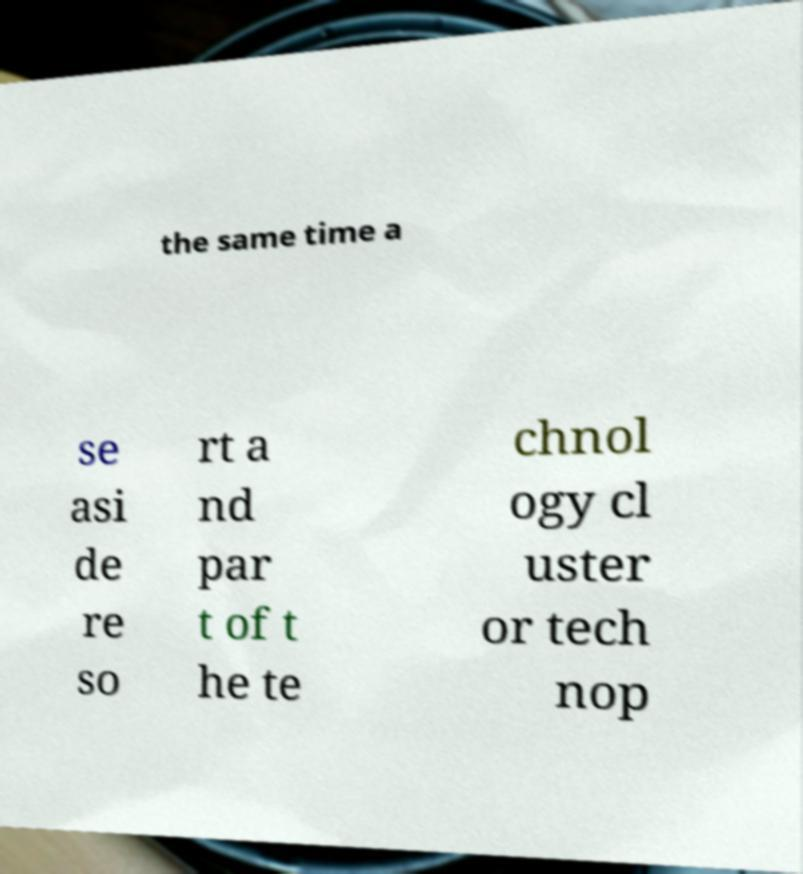Can you accurately transcribe the text from the provided image for me? the same time a se asi de re so rt a nd par t of t he te chnol ogy cl uster or tech nop 